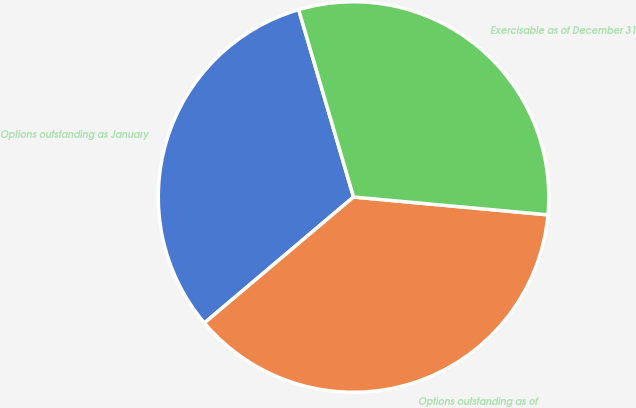<chart> <loc_0><loc_0><loc_500><loc_500><pie_chart><fcel>Options outstanding as January<fcel>Options outstanding as of<fcel>Exercisable as of December 31<nl><fcel>31.63%<fcel>37.38%<fcel>30.99%<nl></chart> 